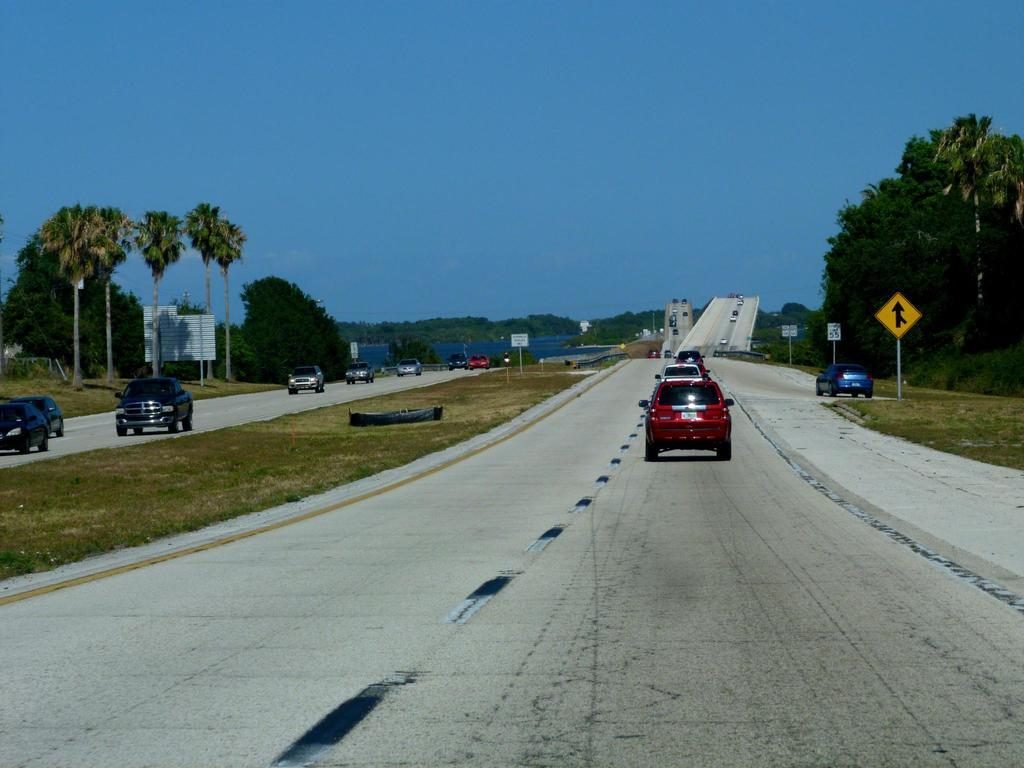What can be seen moving on the road in the image? There are vehicles on the road in the image. What type of information might be conveyed by the sign boards in the image? The sign boards in the image might convey information about directions, warnings, or advertisements. What type of vegetation is present in the image? There are trees and plants in the image. What natural feature can be seen in the image? There is a river visible in the image. What part of the environment is visible in the image? The sky is visible in the image. Can you tell me where the secretary is sitting in the image? There is no secretary present in the image. What type of crook is visible in the image? There is no crook present in the image. 